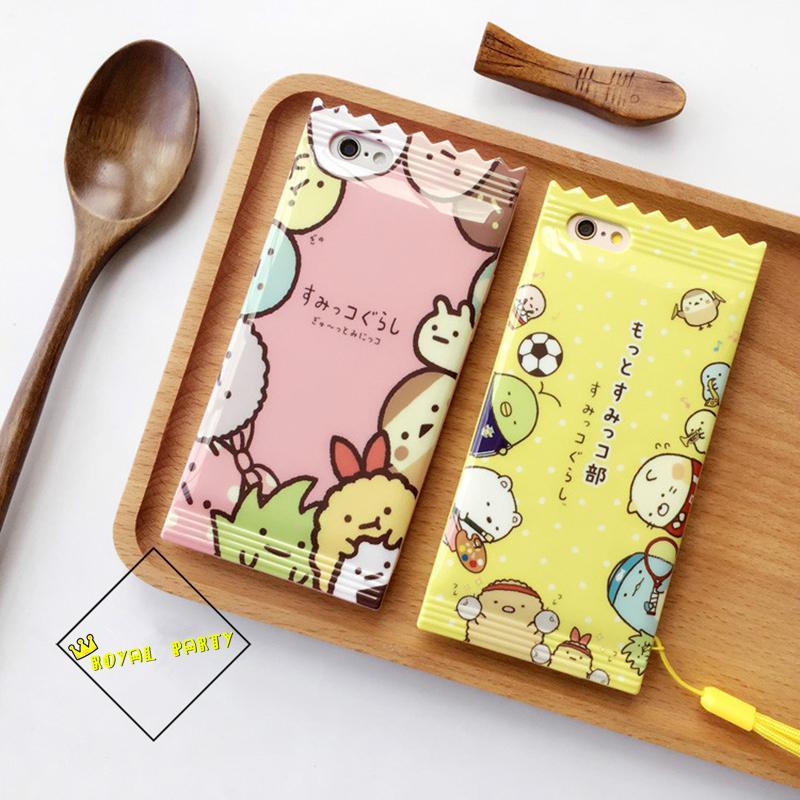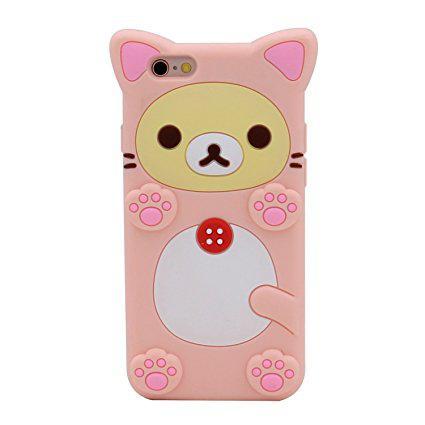The first image is the image on the left, the second image is the image on the right. Examine the images to the left and right. Is the description "The right image shows a rectangular device decorated with a cartoon cat face and at least one paw print." accurate? Answer yes or no. Yes. The first image is the image on the left, the second image is the image on the right. Examine the images to the left and right. Is the description "All of the iPhone cases in the images have a clear back that is decorated with flower blossoms." accurate? Answer yes or no. No. 